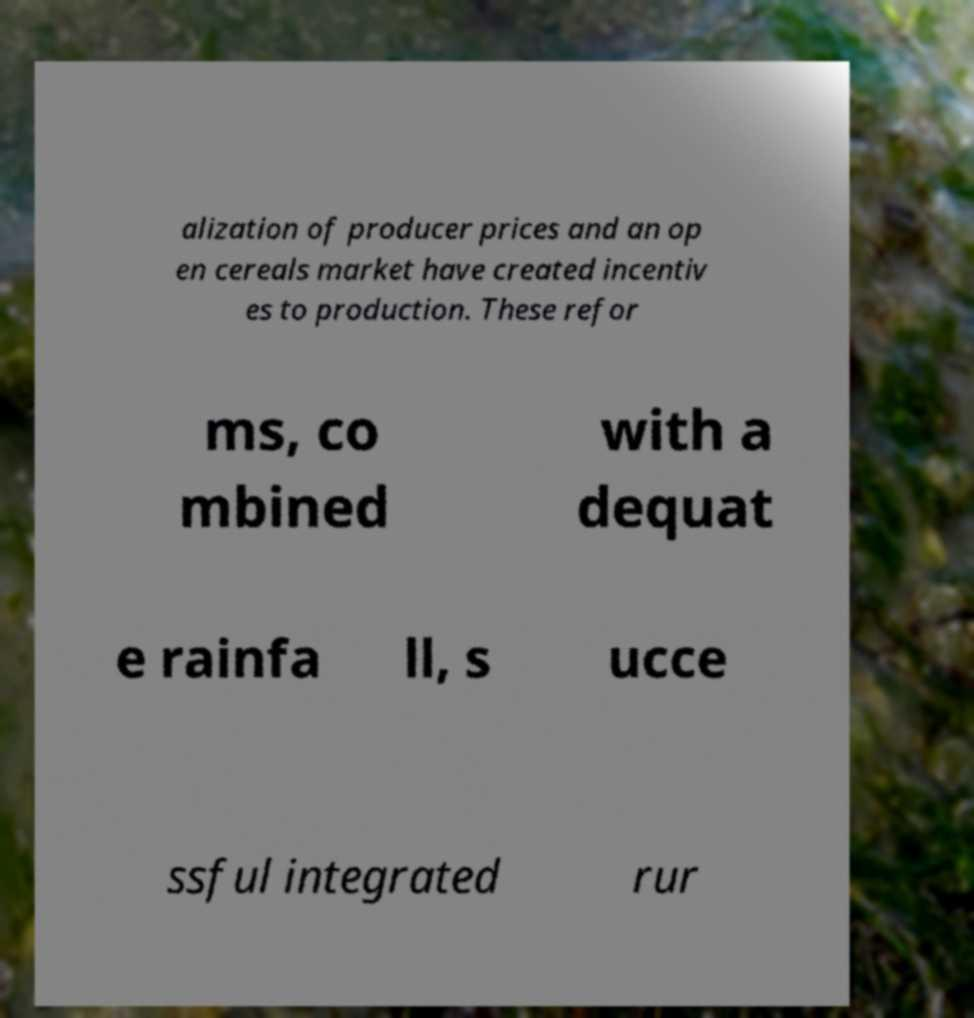There's text embedded in this image that I need extracted. Can you transcribe it verbatim? alization of producer prices and an op en cereals market have created incentiv es to production. These refor ms, co mbined with a dequat e rainfa ll, s ucce ssful integrated rur 